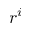Convert formula to latex. <formula><loc_0><loc_0><loc_500><loc_500>r ^ { i }</formula> 